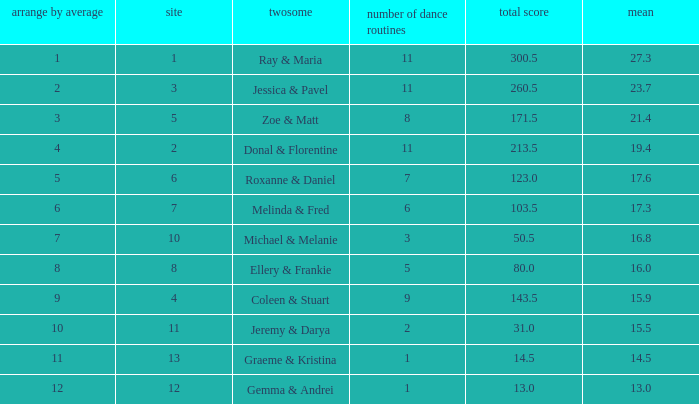What is the couples name where the average is 15.9? Coleen & Stuart. 